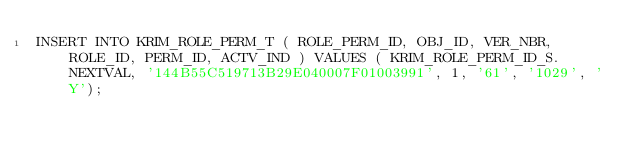<code> <loc_0><loc_0><loc_500><loc_500><_SQL_>INSERT INTO KRIM_ROLE_PERM_T ( ROLE_PERM_ID, OBJ_ID, VER_NBR, ROLE_ID, PERM_ID, ACTV_IND ) VALUES ( KRIM_ROLE_PERM_ID_S.NEXTVAL, '144B55C519713B29E040007F01003991', 1, '61', '1029', 'Y');
</code> 